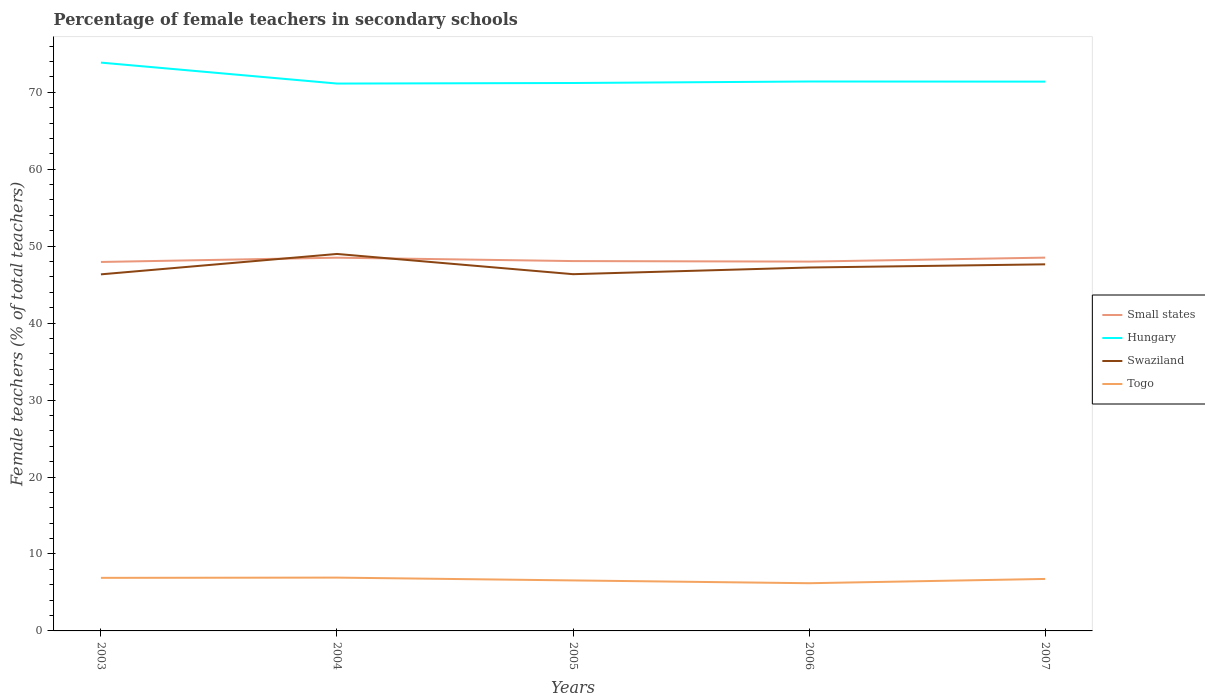Does the line corresponding to Hungary intersect with the line corresponding to Small states?
Provide a succinct answer. No. Is the number of lines equal to the number of legend labels?
Give a very brief answer. Yes. Across all years, what is the maximum percentage of female teachers in Swaziland?
Offer a very short reply. 46.34. What is the total percentage of female teachers in Swaziland in the graph?
Your answer should be compact. -2.65. What is the difference between the highest and the second highest percentage of female teachers in Small states?
Provide a short and direct response. 0.56. What is the difference between the highest and the lowest percentage of female teachers in Small states?
Provide a succinct answer. 2. Is the percentage of female teachers in Swaziland strictly greater than the percentage of female teachers in Togo over the years?
Your response must be concise. No. What is the difference between two consecutive major ticks on the Y-axis?
Your answer should be very brief. 10. Does the graph contain any zero values?
Make the answer very short. No. Does the graph contain grids?
Make the answer very short. No. Where does the legend appear in the graph?
Your response must be concise. Center right. What is the title of the graph?
Offer a terse response. Percentage of female teachers in secondary schools. Does "Bulgaria" appear as one of the legend labels in the graph?
Offer a terse response. No. What is the label or title of the Y-axis?
Provide a succinct answer. Female teachers (% of total teachers). What is the Female teachers (% of total teachers) in Small states in 2003?
Your answer should be very brief. 47.94. What is the Female teachers (% of total teachers) in Hungary in 2003?
Give a very brief answer. 73.85. What is the Female teachers (% of total teachers) in Swaziland in 2003?
Give a very brief answer. 46.34. What is the Female teachers (% of total teachers) in Togo in 2003?
Your answer should be very brief. 6.9. What is the Female teachers (% of total teachers) of Small states in 2004?
Your response must be concise. 48.5. What is the Female teachers (% of total teachers) of Hungary in 2004?
Give a very brief answer. 71.13. What is the Female teachers (% of total teachers) in Swaziland in 2004?
Offer a terse response. 48.99. What is the Female teachers (% of total teachers) in Togo in 2004?
Provide a succinct answer. 6.93. What is the Female teachers (% of total teachers) in Small states in 2005?
Your response must be concise. 48.06. What is the Female teachers (% of total teachers) in Hungary in 2005?
Your answer should be very brief. 71.2. What is the Female teachers (% of total teachers) in Swaziland in 2005?
Provide a short and direct response. 46.36. What is the Female teachers (% of total teachers) of Togo in 2005?
Provide a short and direct response. 6.56. What is the Female teachers (% of total teachers) of Small states in 2006?
Your response must be concise. 47.99. What is the Female teachers (% of total teachers) in Hungary in 2006?
Your response must be concise. 71.4. What is the Female teachers (% of total teachers) in Swaziland in 2006?
Your answer should be compact. 47.22. What is the Female teachers (% of total teachers) in Togo in 2006?
Offer a very short reply. 6.2. What is the Female teachers (% of total teachers) in Small states in 2007?
Offer a terse response. 48.51. What is the Female teachers (% of total teachers) of Hungary in 2007?
Your answer should be very brief. 71.38. What is the Female teachers (% of total teachers) of Swaziland in 2007?
Keep it short and to the point. 47.64. What is the Female teachers (% of total teachers) in Togo in 2007?
Your answer should be very brief. 6.75. Across all years, what is the maximum Female teachers (% of total teachers) in Small states?
Give a very brief answer. 48.51. Across all years, what is the maximum Female teachers (% of total teachers) in Hungary?
Provide a short and direct response. 73.85. Across all years, what is the maximum Female teachers (% of total teachers) in Swaziland?
Provide a short and direct response. 48.99. Across all years, what is the maximum Female teachers (% of total teachers) of Togo?
Ensure brevity in your answer.  6.93. Across all years, what is the minimum Female teachers (% of total teachers) in Small states?
Offer a terse response. 47.94. Across all years, what is the minimum Female teachers (% of total teachers) in Hungary?
Make the answer very short. 71.13. Across all years, what is the minimum Female teachers (% of total teachers) in Swaziland?
Provide a short and direct response. 46.34. Across all years, what is the minimum Female teachers (% of total teachers) in Togo?
Provide a short and direct response. 6.2. What is the total Female teachers (% of total teachers) in Small states in the graph?
Your answer should be very brief. 241.01. What is the total Female teachers (% of total teachers) in Hungary in the graph?
Ensure brevity in your answer.  358.95. What is the total Female teachers (% of total teachers) of Swaziland in the graph?
Ensure brevity in your answer.  236.54. What is the total Female teachers (% of total teachers) in Togo in the graph?
Offer a very short reply. 33.34. What is the difference between the Female teachers (% of total teachers) in Small states in 2003 and that in 2004?
Give a very brief answer. -0.56. What is the difference between the Female teachers (% of total teachers) in Hungary in 2003 and that in 2004?
Give a very brief answer. 2.72. What is the difference between the Female teachers (% of total teachers) of Swaziland in 2003 and that in 2004?
Your answer should be compact. -2.65. What is the difference between the Female teachers (% of total teachers) in Togo in 2003 and that in 2004?
Give a very brief answer. -0.03. What is the difference between the Female teachers (% of total teachers) in Small states in 2003 and that in 2005?
Provide a succinct answer. -0.12. What is the difference between the Female teachers (% of total teachers) of Hungary in 2003 and that in 2005?
Ensure brevity in your answer.  2.65. What is the difference between the Female teachers (% of total teachers) in Swaziland in 2003 and that in 2005?
Provide a short and direct response. -0.02. What is the difference between the Female teachers (% of total teachers) of Togo in 2003 and that in 2005?
Your response must be concise. 0.33. What is the difference between the Female teachers (% of total teachers) in Small states in 2003 and that in 2006?
Make the answer very short. -0.05. What is the difference between the Female teachers (% of total teachers) in Hungary in 2003 and that in 2006?
Ensure brevity in your answer.  2.46. What is the difference between the Female teachers (% of total teachers) of Swaziland in 2003 and that in 2006?
Keep it short and to the point. -0.89. What is the difference between the Female teachers (% of total teachers) in Togo in 2003 and that in 2006?
Provide a short and direct response. 0.7. What is the difference between the Female teachers (% of total teachers) in Small states in 2003 and that in 2007?
Offer a very short reply. -0.56. What is the difference between the Female teachers (% of total teachers) in Hungary in 2003 and that in 2007?
Keep it short and to the point. 2.47. What is the difference between the Female teachers (% of total teachers) in Swaziland in 2003 and that in 2007?
Your response must be concise. -1.3. What is the difference between the Female teachers (% of total teachers) in Togo in 2003 and that in 2007?
Your answer should be very brief. 0.14. What is the difference between the Female teachers (% of total teachers) in Small states in 2004 and that in 2005?
Offer a terse response. 0.44. What is the difference between the Female teachers (% of total teachers) in Hungary in 2004 and that in 2005?
Provide a short and direct response. -0.07. What is the difference between the Female teachers (% of total teachers) of Swaziland in 2004 and that in 2005?
Provide a short and direct response. 2.63. What is the difference between the Female teachers (% of total teachers) of Togo in 2004 and that in 2005?
Offer a very short reply. 0.37. What is the difference between the Female teachers (% of total teachers) of Small states in 2004 and that in 2006?
Offer a very short reply. 0.51. What is the difference between the Female teachers (% of total teachers) of Hungary in 2004 and that in 2006?
Keep it short and to the point. -0.27. What is the difference between the Female teachers (% of total teachers) in Swaziland in 2004 and that in 2006?
Give a very brief answer. 1.76. What is the difference between the Female teachers (% of total teachers) of Togo in 2004 and that in 2006?
Provide a succinct answer. 0.73. What is the difference between the Female teachers (% of total teachers) of Small states in 2004 and that in 2007?
Keep it short and to the point. -0.01. What is the difference between the Female teachers (% of total teachers) of Hungary in 2004 and that in 2007?
Give a very brief answer. -0.25. What is the difference between the Female teachers (% of total teachers) in Swaziland in 2004 and that in 2007?
Make the answer very short. 1.35. What is the difference between the Female teachers (% of total teachers) in Togo in 2004 and that in 2007?
Offer a terse response. 0.17. What is the difference between the Female teachers (% of total teachers) of Small states in 2005 and that in 2006?
Ensure brevity in your answer.  0.07. What is the difference between the Female teachers (% of total teachers) in Hungary in 2005 and that in 2006?
Offer a very short reply. -0.2. What is the difference between the Female teachers (% of total teachers) of Swaziland in 2005 and that in 2006?
Give a very brief answer. -0.87. What is the difference between the Female teachers (% of total teachers) in Togo in 2005 and that in 2006?
Make the answer very short. 0.36. What is the difference between the Female teachers (% of total teachers) in Small states in 2005 and that in 2007?
Offer a terse response. -0.45. What is the difference between the Female teachers (% of total teachers) of Hungary in 2005 and that in 2007?
Your answer should be very brief. -0.18. What is the difference between the Female teachers (% of total teachers) in Swaziland in 2005 and that in 2007?
Keep it short and to the point. -1.28. What is the difference between the Female teachers (% of total teachers) in Togo in 2005 and that in 2007?
Offer a terse response. -0.19. What is the difference between the Female teachers (% of total teachers) of Small states in 2006 and that in 2007?
Provide a short and direct response. -0.52. What is the difference between the Female teachers (% of total teachers) in Hungary in 2006 and that in 2007?
Give a very brief answer. 0.02. What is the difference between the Female teachers (% of total teachers) in Swaziland in 2006 and that in 2007?
Provide a succinct answer. -0.41. What is the difference between the Female teachers (% of total teachers) in Togo in 2006 and that in 2007?
Offer a terse response. -0.56. What is the difference between the Female teachers (% of total teachers) in Small states in 2003 and the Female teachers (% of total teachers) in Hungary in 2004?
Keep it short and to the point. -23.18. What is the difference between the Female teachers (% of total teachers) of Small states in 2003 and the Female teachers (% of total teachers) of Swaziland in 2004?
Offer a terse response. -1.04. What is the difference between the Female teachers (% of total teachers) in Small states in 2003 and the Female teachers (% of total teachers) in Togo in 2004?
Make the answer very short. 41.02. What is the difference between the Female teachers (% of total teachers) in Hungary in 2003 and the Female teachers (% of total teachers) in Swaziland in 2004?
Offer a terse response. 24.86. What is the difference between the Female teachers (% of total teachers) in Hungary in 2003 and the Female teachers (% of total teachers) in Togo in 2004?
Provide a succinct answer. 66.92. What is the difference between the Female teachers (% of total teachers) in Swaziland in 2003 and the Female teachers (% of total teachers) in Togo in 2004?
Ensure brevity in your answer.  39.41. What is the difference between the Female teachers (% of total teachers) of Small states in 2003 and the Female teachers (% of total teachers) of Hungary in 2005?
Give a very brief answer. -23.26. What is the difference between the Female teachers (% of total teachers) in Small states in 2003 and the Female teachers (% of total teachers) in Swaziland in 2005?
Your answer should be compact. 1.59. What is the difference between the Female teachers (% of total teachers) in Small states in 2003 and the Female teachers (% of total teachers) in Togo in 2005?
Provide a succinct answer. 41.38. What is the difference between the Female teachers (% of total teachers) of Hungary in 2003 and the Female teachers (% of total teachers) of Swaziland in 2005?
Provide a short and direct response. 27.49. What is the difference between the Female teachers (% of total teachers) in Hungary in 2003 and the Female teachers (% of total teachers) in Togo in 2005?
Offer a terse response. 67.29. What is the difference between the Female teachers (% of total teachers) in Swaziland in 2003 and the Female teachers (% of total teachers) in Togo in 2005?
Make the answer very short. 39.77. What is the difference between the Female teachers (% of total teachers) of Small states in 2003 and the Female teachers (% of total teachers) of Hungary in 2006?
Give a very brief answer. -23.45. What is the difference between the Female teachers (% of total teachers) of Small states in 2003 and the Female teachers (% of total teachers) of Swaziland in 2006?
Your answer should be compact. 0.72. What is the difference between the Female teachers (% of total teachers) of Small states in 2003 and the Female teachers (% of total teachers) of Togo in 2006?
Give a very brief answer. 41.75. What is the difference between the Female teachers (% of total teachers) of Hungary in 2003 and the Female teachers (% of total teachers) of Swaziland in 2006?
Offer a terse response. 26.63. What is the difference between the Female teachers (% of total teachers) of Hungary in 2003 and the Female teachers (% of total teachers) of Togo in 2006?
Offer a terse response. 67.65. What is the difference between the Female teachers (% of total teachers) of Swaziland in 2003 and the Female teachers (% of total teachers) of Togo in 2006?
Ensure brevity in your answer.  40.14. What is the difference between the Female teachers (% of total teachers) in Small states in 2003 and the Female teachers (% of total teachers) in Hungary in 2007?
Provide a succinct answer. -23.43. What is the difference between the Female teachers (% of total teachers) of Small states in 2003 and the Female teachers (% of total teachers) of Swaziland in 2007?
Provide a short and direct response. 0.31. What is the difference between the Female teachers (% of total teachers) in Small states in 2003 and the Female teachers (% of total teachers) in Togo in 2007?
Provide a short and direct response. 41.19. What is the difference between the Female teachers (% of total teachers) of Hungary in 2003 and the Female teachers (% of total teachers) of Swaziland in 2007?
Your answer should be very brief. 26.21. What is the difference between the Female teachers (% of total teachers) of Hungary in 2003 and the Female teachers (% of total teachers) of Togo in 2007?
Offer a very short reply. 67.1. What is the difference between the Female teachers (% of total teachers) of Swaziland in 2003 and the Female teachers (% of total teachers) of Togo in 2007?
Offer a terse response. 39.58. What is the difference between the Female teachers (% of total teachers) in Small states in 2004 and the Female teachers (% of total teachers) in Hungary in 2005?
Make the answer very short. -22.7. What is the difference between the Female teachers (% of total teachers) in Small states in 2004 and the Female teachers (% of total teachers) in Swaziland in 2005?
Offer a very short reply. 2.14. What is the difference between the Female teachers (% of total teachers) of Small states in 2004 and the Female teachers (% of total teachers) of Togo in 2005?
Give a very brief answer. 41.94. What is the difference between the Female teachers (% of total teachers) of Hungary in 2004 and the Female teachers (% of total teachers) of Swaziland in 2005?
Make the answer very short. 24.77. What is the difference between the Female teachers (% of total teachers) of Hungary in 2004 and the Female teachers (% of total teachers) of Togo in 2005?
Your response must be concise. 64.57. What is the difference between the Female teachers (% of total teachers) in Swaziland in 2004 and the Female teachers (% of total teachers) in Togo in 2005?
Your answer should be very brief. 42.42. What is the difference between the Female teachers (% of total teachers) in Small states in 2004 and the Female teachers (% of total teachers) in Hungary in 2006?
Offer a very short reply. -22.89. What is the difference between the Female teachers (% of total teachers) of Small states in 2004 and the Female teachers (% of total teachers) of Swaziland in 2006?
Ensure brevity in your answer.  1.28. What is the difference between the Female teachers (% of total teachers) of Small states in 2004 and the Female teachers (% of total teachers) of Togo in 2006?
Offer a very short reply. 42.3. What is the difference between the Female teachers (% of total teachers) in Hungary in 2004 and the Female teachers (% of total teachers) in Swaziland in 2006?
Provide a succinct answer. 23.9. What is the difference between the Female teachers (% of total teachers) in Hungary in 2004 and the Female teachers (% of total teachers) in Togo in 2006?
Make the answer very short. 64.93. What is the difference between the Female teachers (% of total teachers) in Swaziland in 2004 and the Female teachers (% of total teachers) in Togo in 2006?
Provide a succinct answer. 42.79. What is the difference between the Female teachers (% of total teachers) of Small states in 2004 and the Female teachers (% of total teachers) of Hungary in 2007?
Keep it short and to the point. -22.88. What is the difference between the Female teachers (% of total teachers) of Small states in 2004 and the Female teachers (% of total teachers) of Swaziland in 2007?
Make the answer very short. 0.86. What is the difference between the Female teachers (% of total teachers) of Small states in 2004 and the Female teachers (% of total teachers) of Togo in 2007?
Make the answer very short. 41.75. What is the difference between the Female teachers (% of total teachers) in Hungary in 2004 and the Female teachers (% of total teachers) in Swaziland in 2007?
Your answer should be compact. 23.49. What is the difference between the Female teachers (% of total teachers) of Hungary in 2004 and the Female teachers (% of total teachers) of Togo in 2007?
Give a very brief answer. 64.37. What is the difference between the Female teachers (% of total teachers) of Swaziland in 2004 and the Female teachers (% of total teachers) of Togo in 2007?
Keep it short and to the point. 42.23. What is the difference between the Female teachers (% of total teachers) of Small states in 2005 and the Female teachers (% of total teachers) of Hungary in 2006?
Offer a terse response. -23.34. What is the difference between the Female teachers (% of total teachers) of Small states in 2005 and the Female teachers (% of total teachers) of Swaziland in 2006?
Your answer should be very brief. 0.84. What is the difference between the Female teachers (% of total teachers) of Small states in 2005 and the Female teachers (% of total teachers) of Togo in 2006?
Ensure brevity in your answer.  41.86. What is the difference between the Female teachers (% of total teachers) of Hungary in 2005 and the Female teachers (% of total teachers) of Swaziland in 2006?
Provide a short and direct response. 23.98. What is the difference between the Female teachers (% of total teachers) of Hungary in 2005 and the Female teachers (% of total teachers) of Togo in 2006?
Keep it short and to the point. 65. What is the difference between the Female teachers (% of total teachers) of Swaziland in 2005 and the Female teachers (% of total teachers) of Togo in 2006?
Offer a terse response. 40.16. What is the difference between the Female teachers (% of total teachers) in Small states in 2005 and the Female teachers (% of total teachers) in Hungary in 2007?
Offer a terse response. -23.32. What is the difference between the Female teachers (% of total teachers) of Small states in 2005 and the Female teachers (% of total teachers) of Swaziland in 2007?
Provide a short and direct response. 0.42. What is the difference between the Female teachers (% of total teachers) in Small states in 2005 and the Female teachers (% of total teachers) in Togo in 2007?
Ensure brevity in your answer.  41.31. What is the difference between the Female teachers (% of total teachers) of Hungary in 2005 and the Female teachers (% of total teachers) of Swaziland in 2007?
Keep it short and to the point. 23.56. What is the difference between the Female teachers (% of total teachers) in Hungary in 2005 and the Female teachers (% of total teachers) in Togo in 2007?
Keep it short and to the point. 64.45. What is the difference between the Female teachers (% of total teachers) of Swaziland in 2005 and the Female teachers (% of total teachers) of Togo in 2007?
Provide a short and direct response. 39.6. What is the difference between the Female teachers (% of total teachers) in Small states in 2006 and the Female teachers (% of total teachers) in Hungary in 2007?
Provide a succinct answer. -23.39. What is the difference between the Female teachers (% of total teachers) in Small states in 2006 and the Female teachers (% of total teachers) in Swaziland in 2007?
Your response must be concise. 0.36. What is the difference between the Female teachers (% of total teachers) in Small states in 2006 and the Female teachers (% of total teachers) in Togo in 2007?
Provide a short and direct response. 41.24. What is the difference between the Female teachers (% of total teachers) of Hungary in 2006 and the Female teachers (% of total teachers) of Swaziland in 2007?
Offer a terse response. 23.76. What is the difference between the Female teachers (% of total teachers) of Hungary in 2006 and the Female teachers (% of total teachers) of Togo in 2007?
Keep it short and to the point. 64.64. What is the difference between the Female teachers (% of total teachers) in Swaziland in 2006 and the Female teachers (% of total teachers) in Togo in 2007?
Give a very brief answer. 40.47. What is the average Female teachers (% of total teachers) of Small states per year?
Provide a succinct answer. 48.2. What is the average Female teachers (% of total teachers) in Hungary per year?
Give a very brief answer. 71.79. What is the average Female teachers (% of total teachers) in Swaziland per year?
Keep it short and to the point. 47.31. What is the average Female teachers (% of total teachers) in Togo per year?
Offer a very short reply. 6.67. In the year 2003, what is the difference between the Female teachers (% of total teachers) of Small states and Female teachers (% of total teachers) of Hungary?
Provide a succinct answer. -25.91. In the year 2003, what is the difference between the Female teachers (% of total teachers) of Small states and Female teachers (% of total teachers) of Swaziland?
Your response must be concise. 1.61. In the year 2003, what is the difference between the Female teachers (% of total teachers) of Small states and Female teachers (% of total teachers) of Togo?
Your response must be concise. 41.05. In the year 2003, what is the difference between the Female teachers (% of total teachers) of Hungary and Female teachers (% of total teachers) of Swaziland?
Provide a succinct answer. 27.52. In the year 2003, what is the difference between the Female teachers (% of total teachers) in Hungary and Female teachers (% of total teachers) in Togo?
Provide a succinct answer. 66.95. In the year 2003, what is the difference between the Female teachers (% of total teachers) of Swaziland and Female teachers (% of total teachers) of Togo?
Your response must be concise. 39.44. In the year 2004, what is the difference between the Female teachers (% of total teachers) of Small states and Female teachers (% of total teachers) of Hungary?
Your answer should be compact. -22.63. In the year 2004, what is the difference between the Female teachers (% of total teachers) of Small states and Female teachers (% of total teachers) of Swaziland?
Offer a very short reply. -0.48. In the year 2004, what is the difference between the Female teachers (% of total teachers) of Small states and Female teachers (% of total teachers) of Togo?
Offer a terse response. 41.57. In the year 2004, what is the difference between the Female teachers (% of total teachers) of Hungary and Female teachers (% of total teachers) of Swaziland?
Ensure brevity in your answer.  22.14. In the year 2004, what is the difference between the Female teachers (% of total teachers) of Hungary and Female teachers (% of total teachers) of Togo?
Provide a succinct answer. 64.2. In the year 2004, what is the difference between the Female teachers (% of total teachers) in Swaziland and Female teachers (% of total teachers) in Togo?
Your response must be concise. 42.06. In the year 2005, what is the difference between the Female teachers (% of total teachers) of Small states and Female teachers (% of total teachers) of Hungary?
Make the answer very short. -23.14. In the year 2005, what is the difference between the Female teachers (% of total teachers) in Small states and Female teachers (% of total teachers) in Swaziland?
Give a very brief answer. 1.7. In the year 2005, what is the difference between the Female teachers (% of total teachers) in Small states and Female teachers (% of total teachers) in Togo?
Give a very brief answer. 41.5. In the year 2005, what is the difference between the Female teachers (% of total teachers) of Hungary and Female teachers (% of total teachers) of Swaziland?
Provide a succinct answer. 24.84. In the year 2005, what is the difference between the Female teachers (% of total teachers) of Hungary and Female teachers (% of total teachers) of Togo?
Offer a very short reply. 64.64. In the year 2005, what is the difference between the Female teachers (% of total teachers) of Swaziland and Female teachers (% of total teachers) of Togo?
Your response must be concise. 39.8. In the year 2006, what is the difference between the Female teachers (% of total teachers) of Small states and Female teachers (% of total teachers) of Hungary?
Your answer should be very brief. -23.4. In the year 2006, what is the difference between the Female teachers (% of total teachers) in Small states and Female teachers (% of total teachers) in Swaziland?
Give a very brief answer. 0.77. In the year 2006, what is the difference between the Female teachers (% of total teachers) of Small states and Female teachers (% of total teachers) of Togo?
Your response must be concise. 41.79. In the year 2006, what is the difference between the Female teachers (% of total teachers) of Hungary and Female teachers (% of total teachers) of Swaziland?
Your answer should be compact. 24.17. In the year 2006, what is the difference between the Female teachers (% of total teachers) in Hungary and Female teachers (% of total teachers) in Togo?
Offer a terse response. 65.2. In the year 2006, what is the difference between the Female teachers (% of total teachers) in Swaziland and Female teachers (% of total teachers) in Togo?
Ensure brevity in your answer.  41.02. In the year 2007, what is the difference between the Female teachers (% of total teachers) of Small states and Female teachers (% of total teachers) of Hungary?
Your answer should be very brief. -22.87. In the year 2007, what is the difference between the Female teachers (% of total teachers) of Small states and Female teachers (% of total teachers) of Swaziland?
Make the answer very short. 0.87. In the year 2007, what is the difference between the Female teachers (% of total teachers) in Small states and Female teachers (% of total teachers) in Togo?
Ensure brevity in your answer.  41.75. In the year 2007, what is the difference between the Female teachers (% of total teachers) of Hungary and Female teachers (% of total teachers) of Swaziland?
Provide a succinct answer. 23.74. In the year 2007, what is the difference between the Female teachers (% of total teachers) of Hungary and Female teachers (% of total teachers) of Togo?
Offer a terse response. 64.62. In the year 2007, what is the difference between the Female teachers (% of total teachers) of Swaziland and Female teachers (% of total teachers) of Togo?
Your answer should be very brief. 40.88. What is the ratio of the Female teachers (% of total teachers) of Small states in 2003 to that in 2004?
Ensure brevity in your answer.  0.99. What is the ratio of the Female teachers (% of total teachers) in Hungary in 2003 to that in 2004?
Make the answer very short. 1.04. What is the ratio of the Female teachers (% of total teachers) in Swaziland in 2003 to that in 2004?
Offer a terse response. 0.95. What is the ratio of the Female teachers (% of total teachers) of Togo in 2003 to that in 2004?
Give a very brief answer. 1. What is the ratio of the Female teachers (% of total teachers) in Hungary in 2003 to that in 2005?
Make the answer very short. 1.04. What is the ratio of the Female teachers (% of total teachers) in Swaziland in 2003 to that in 2005?
Keep it short and to the point. 1. What is the ratio of the Female teachers (% of total teachers) in Togo in 2003 to that in 2005?
Keep it short and to the point. 1.05. What is the ratio of the Female teachers (% of total teachers) of Hungary in 2003 to that in 2006?
Offer a very short reply. 1.03. What is the ratio of the Female teachers (% of total teachers) of Swaziland in 2003 to that in 2006?
Your answer should be very brief. 0.98. What is the ratio of the Female teachers (% of total teachers) of Togo in 2003 to that in 2006?
Keep it short and to the point. 1.11. What is the ratio of the Female teachers (% of total teachers) in Small states in 2003 to that in 2007?
Provide a short and direct response. 0.99. What is the ratio of the Female teachers (% of total teachers) of Hungary in 2003 to that in 2007?
Provide a succinct answer. 1.03. What is the ratio of the Female teachers (% of total teachers) in Swaziland in 2003 to that in 2007?
Offer a terse response. 0.97. What is the ratio of the Female teachers (% of total teachers) in Togo in 2003 to that in 2007?
Provide a succinct answer. 1.02. What is the ratio of the Female teachers (% of total teachers) in Small states in 2004 to that in 2005?
Offer a terse response. 1.01. What is the ratio of the Female teachers (% of total teachers) of Swaziland in 2004 to that in 2005?
Provide a short and direct response. 1.06. What is the ratio of the Female teachers (% of total teachers) of Togo in 2004 to that in 2005?
Ensure brevity in your answer.  1.06. What is the ratio of the Female teachers (% of total teachers) in Small states in 2004 to that in 2006?
Your answer should be compact. 1.01. What is the ratio of the Female teachers (% of total teachers) in Swaziland in 2004 to that in 2006?
Give a very brief answer. 1.04. What is the ratio of the Female teachers (% of total teachers) in Togo in 2004 to that in 2006?
Offer a very short reply. 1.12. What is the ratio of the Female teachers (% of total teachers) of Small states in 2004 to that in 2007?
Your response must be concise. 1. What is the ratio of the Female teachers (% of total teachers) of Swaziland in 2004 to that in 2007?
Provide a short and direct response. 1.03. What is the ratio of the Female teachers (% of total teachers) in Togo in 2004 to that in 2007?
Your answer should be very brief. 1.03. What is the ratio of the Female teachers (% of total teachers) of Small states in 2005 to that in 2006?
Ensure brevity in your answer.  1. What is the ratio of the Female teachers (% of total teachers) of Hungary in 2005 to that in 2006?
Your answer should be very brief. 1. What is the ratio of the Female teachers (% of total teachers) in Swaziland in 2005 to that in 2006?
Offer a very short reply. 0.98. What is the ratio of the Female teachers (% of total teachers) of Togo in 2005 to that in 2006?
Ensure brevity in your answer.  1.06. What is the ratio of the Female teachers (% of total teachers) in Small states in 2005 to that in 2007?
Offer a terse response. 0.99. What is the ratio of the Female teachers (% of total teachers) in Swaziland in 2005 to that in 2007?
Ensure brevity in your answer.  0.97. What is the ratio of the Female teachers (% of total teachers) in Togo in 2005 to that in 2007?
Your response must be concise. 0.97. What is the ratio of the Female teachers (% of total teachers) in Small states in 2006 to that in 2007?
Provide a short and direct response. 0.99. What is the ratio of the Female teachers (% of total teachers) of Hungary in 2006 to that in 2007?
Provide a succinct answer. 1. What is the ratio of the Female teachers (% of total teachers) in Togo in 2006 to that in 2007?
Your answer should be compact. 0.92. What is the difference between the highest and the second highest Female teachers (% of total teachers) in Small states?
Make the answer very short. 0.01. What is the difference between the highest and the second highest Female teachers (% of total teachers) of Hungary?
Your answer should be very brief. 2.46. What is the difference between the highest and the second highest Female teachers (% of total teachers) of Swaziland?
Make the answer very short. 1.35. What is the difference between the highest and the second highest Female teachers (% of total teachers) in Togo?
Your answer should be very brief. 0.03. What is the difference between the highest and the lowest Female teachers (% of total teachers) of Small states?
Offer a very short reply. 0.56. What is the difference between the highest and the lowest Female teachers (% of total teachers) of Hungary?
Your answer should be compact. 2.72. What is the difference between the highest and the lowest Female teachers (% of total teachers) of Swaziland?
Your answer should be compact. 2.65. What is the difference between the highest and the lowest Female teachers (% of total teachers) of Togo?
Provide a short and direct response. 0.73. 